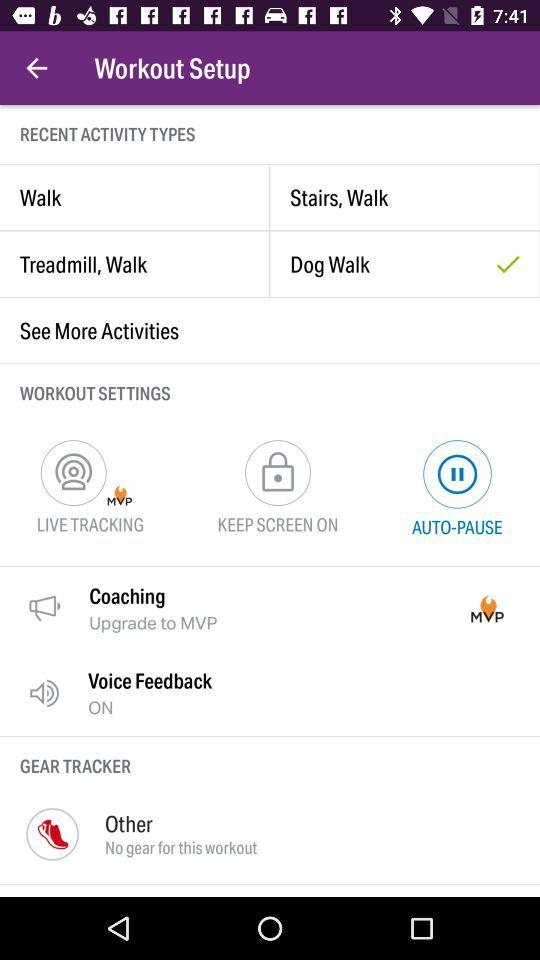How many activity types are there?
Answer the question using a single word or phrase. 4 